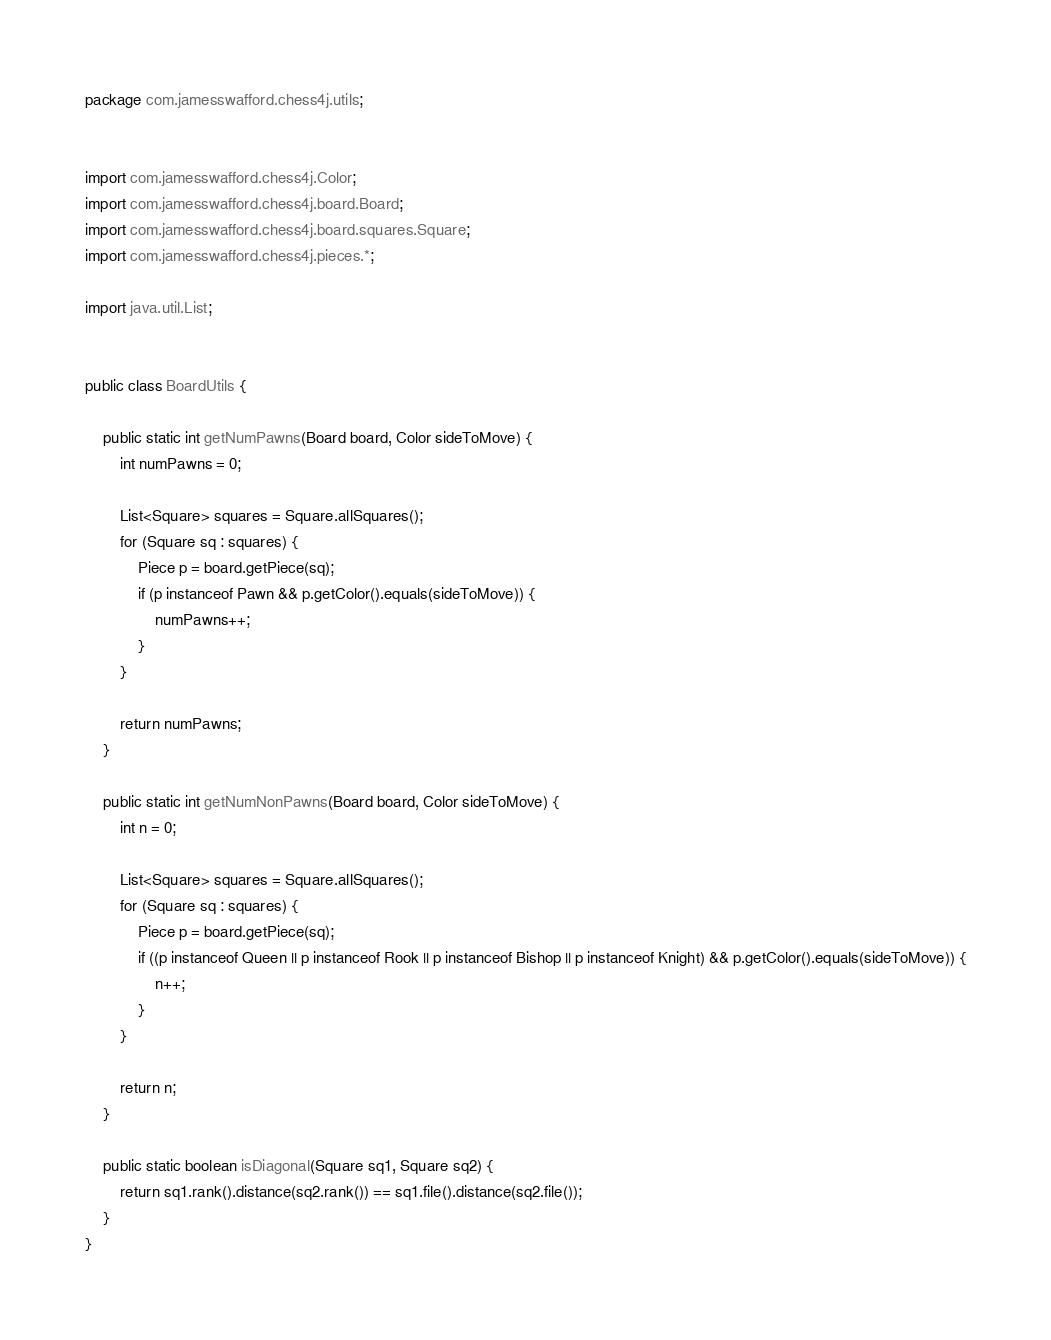<code> <loc_0><loc_0><loc_500><loc_500><_Java_>package com.jamesswafford.chess4j.utils;


import com.jamesswafford.chess4j.Color;
import com.jamesswafford.chess4j.board.Board;
import com.jamesswafford.chess4j.board.squares.Square;
import com.jamesswafford.chess4j.pieces.*;

import java.util.List;


public class BoardUtils {

    public static int getNumPawns(Board board, Color sideToMove) {
        int numPawns = 0;

        List<Square> squares = Square.allSquares();
        for (Square sq : squares) {
            Piece p = board.getPiece(sq);
            if (p instanceof Pawn && p.getColor().equals(sideToMove)) {
                numPawns++;
            }
        }

        return numPawns;
    }

    public static int getNumNonPawns(Board board, Color sideToMove) {
        int n = 0;

        List<Square> squares = Square.allSquares();
        for (Square sq : squares) {
            Piece p = board.getPiece(sq);
            if ((p instanceof Queen || p instanceof Rook || p instanceof Bishop || p instanceof Knight) && p.getColor().equals(sideToMove)) {
                n++;
            }
        }

        return n;
    }

    public static boolean isDiagonal(Square sq1, Square sq2) {
        return sq1.rank().distance(sq2.rank()) == sq1.file().distance(sq2.file());
    }
}
</code> 